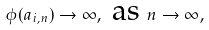<formula> <loc_0><loc_0><loc_500><loc_500>\phi ( a _ { i , n } ) \rightarrow \infty , \text { as } n \rightarrow \infty ,</formula> 